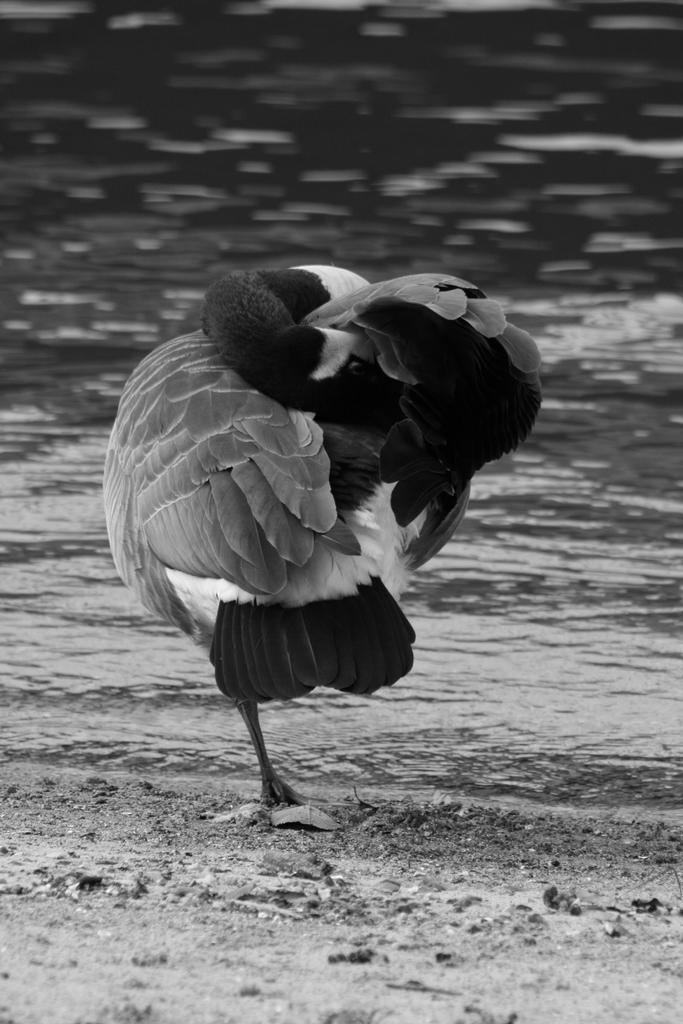What type of animal can be seen in the image? There is a bird in the image. Where is the bird located in the image? The bird is standing in the center of the image. What is the bird's belief about the concept of death in the image? There is no information about the bird's beliefs or thoughts in the image, as it is a static representation of the bird. 